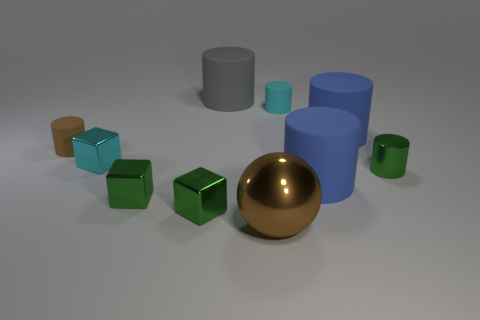There is a brown metal object; what shape is it?
Give a very brief answer. Sphere. There is a rubber cylinder that is the same color as the sphere; what is its size?
Offer a very short reply. Small. What is the color of the other tiny thing that is made of the same material as the small brown thing?
Your response must be concise. Cyan. Do the brown cylinder and the large cylinder left of the large sphere have the same material?
Provide a short and direct response. Yes. The shiny cylinder has what color?
Offer a terse response. Green. There is a cyan thing that is made of the same material as the gray cylinder; what is its size?
Ensure brevity in your answer.  Small. How many tiny cyan rubber cylinders are on the left side of the matte cylinder in front of the cyan thing on the left side of the cyan matte object?
Your answer should be very brief. 1. Does the large shiny sphere have the same color as the tiny rubber cylinder that is right of the gray object?
Your answer should be compact. No. There is a tiny thing that is the same color as the large metallic ball; what is its shape?
Ensure brevity in your answer.  Cylinder. The blue cylinder in front of the small cyan thing that is on the left side of the small rubber thing to the right of the small brown rubber object is made of what material?
Provide a succinct answer. Rubber. 